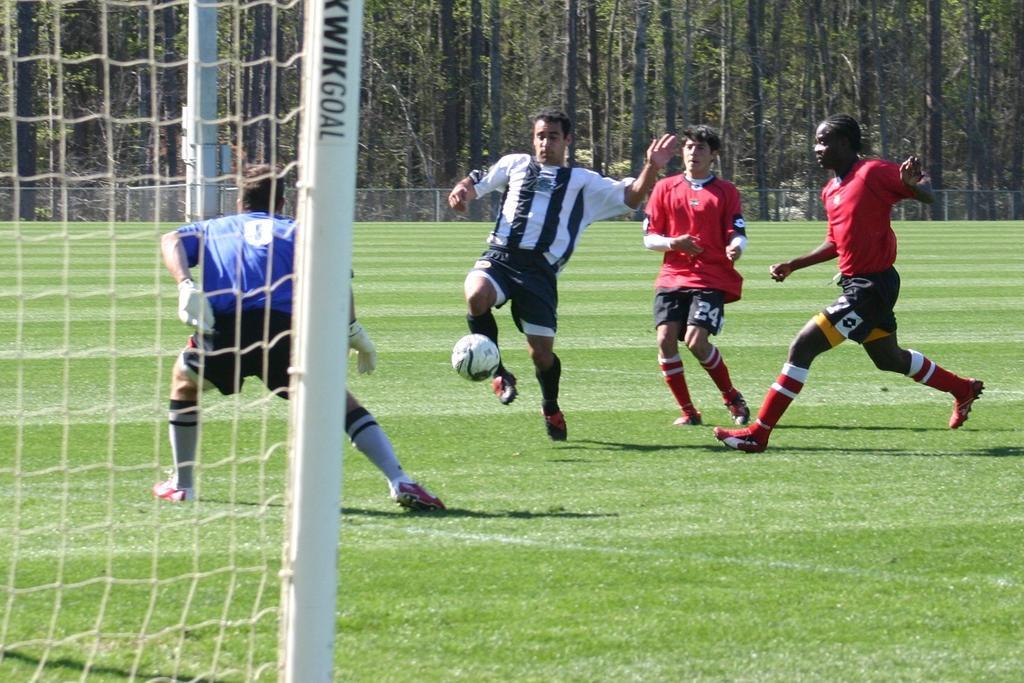Could you give a brief overview of what you see in this image? In this Image I see 4 men who are wearing different colors of jersey and they're on the grass and I see a ball over here, I can also see a net over here and In the background I see the trees. 